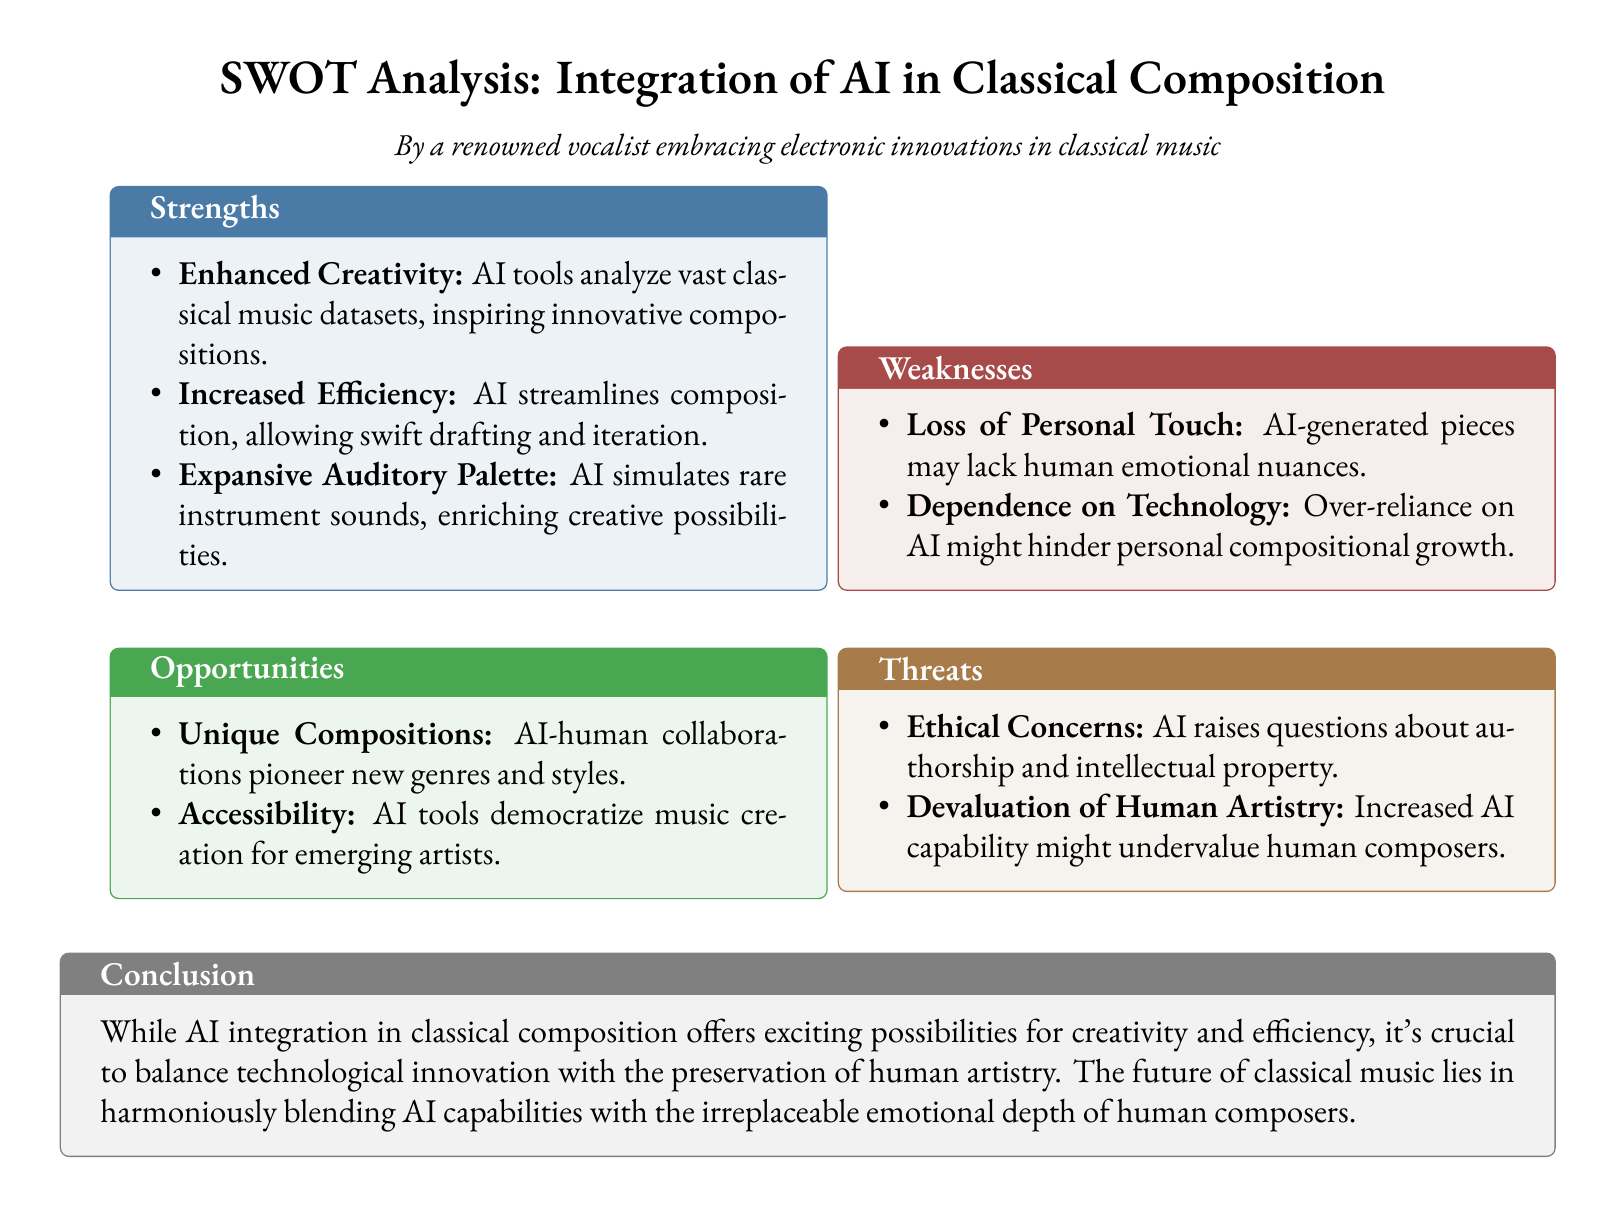What are the strengths listed in the SWOT analysis? The strengths are categorized in the document, specifically highlighting enhanced creativity, increased efficiency, and an expansive auditory palette.
Answer: Enhanced Creativity, Increased Efficiency, Expansive Auditory Palette What is one weakness of AI in composition? The document mentions specific weaknesses, including loss of personal touch as a significant concern.
Answer: Loss of Personal Touch What unique opportunity does AI offer in music composition? The opportunities outlined in the document emphasize unique compositions resulting from AI-human collaborations.
Answer: Unique Compositions What ethical concern is raised regarding AI-generated art? The document points to ethical concerns about authorship and intellectual property related to AI in music composition.
Answer: Authorship and Intellectual Property How does AI increase efficiency in composition? The document explains that AI streamlines composition, allowing for swift drafting and iteration.
Answer: Swift drafting and iteration What might happen to human artistry due to increased AI capability? The document warns that the rise of AI could lead to the devaluation of human artistry.
Answer: Devaluation of Human Artistry What is the conclusion of the SWOT analysis? The conclusion emphasizes the need to balance technological innovation with human artistry preservation.
Answer: Balance technological innovation with preservation of human artistry 